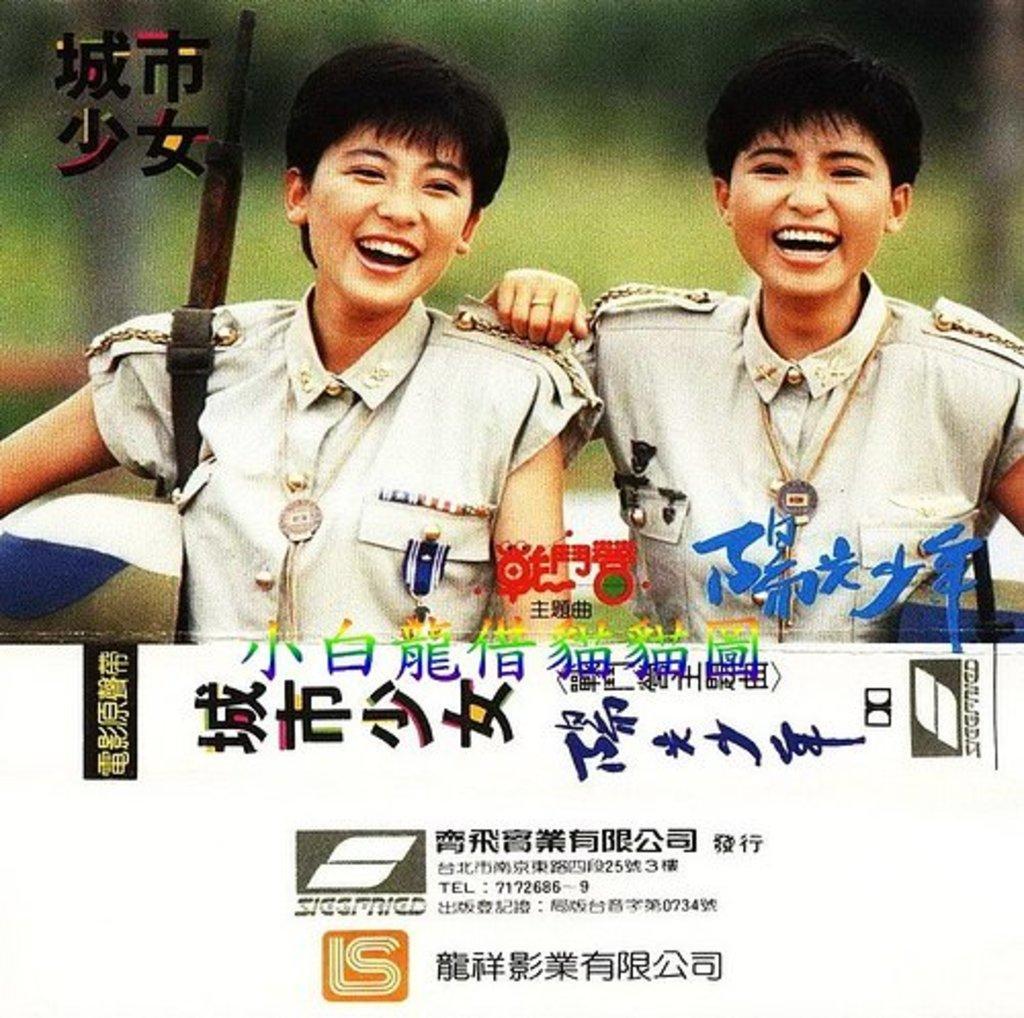Could you give a brief overview of what you see in this image? This image looks like a poster. There are two persons in this image. They are wearing the same dress. There is something written under that. 